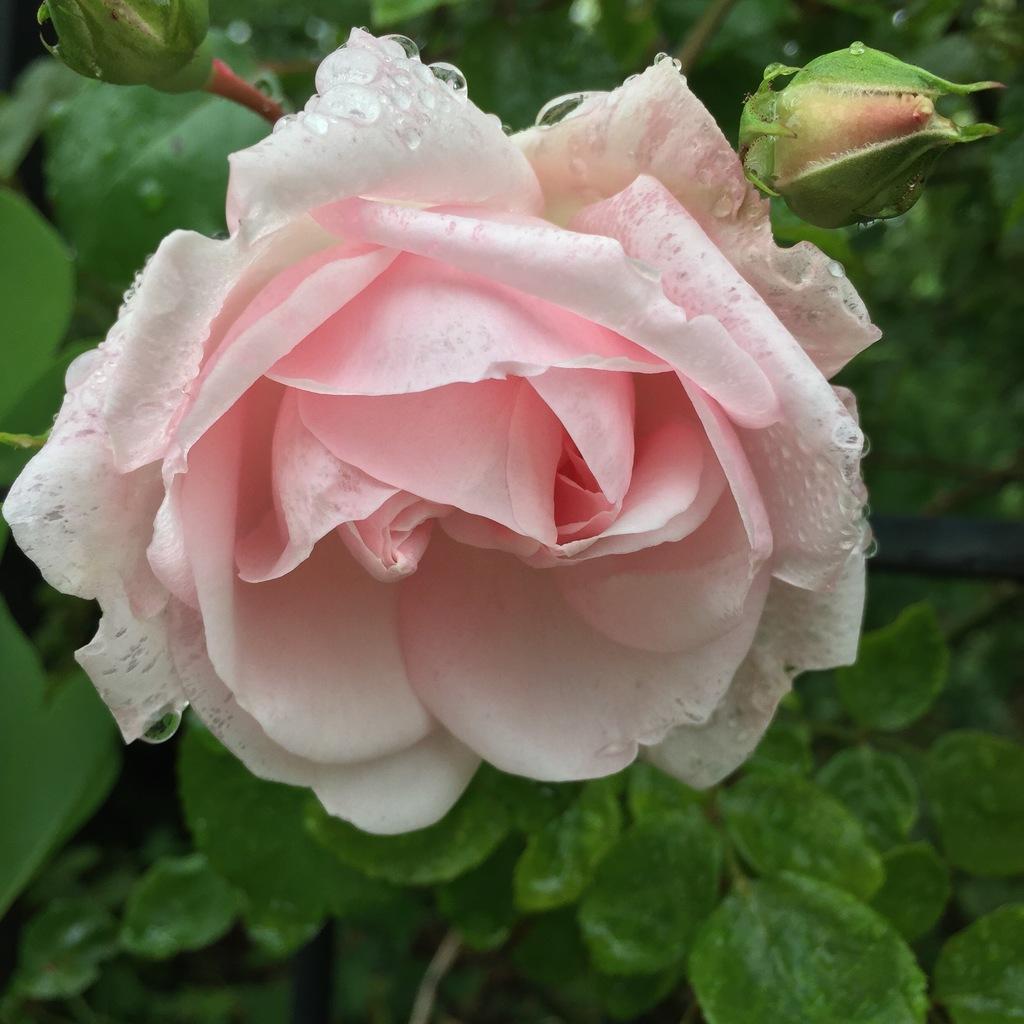Describe this image in one or two sentences. In this picture we can see a light pink rose flower and a few buds. There are some green leaves in the background. 